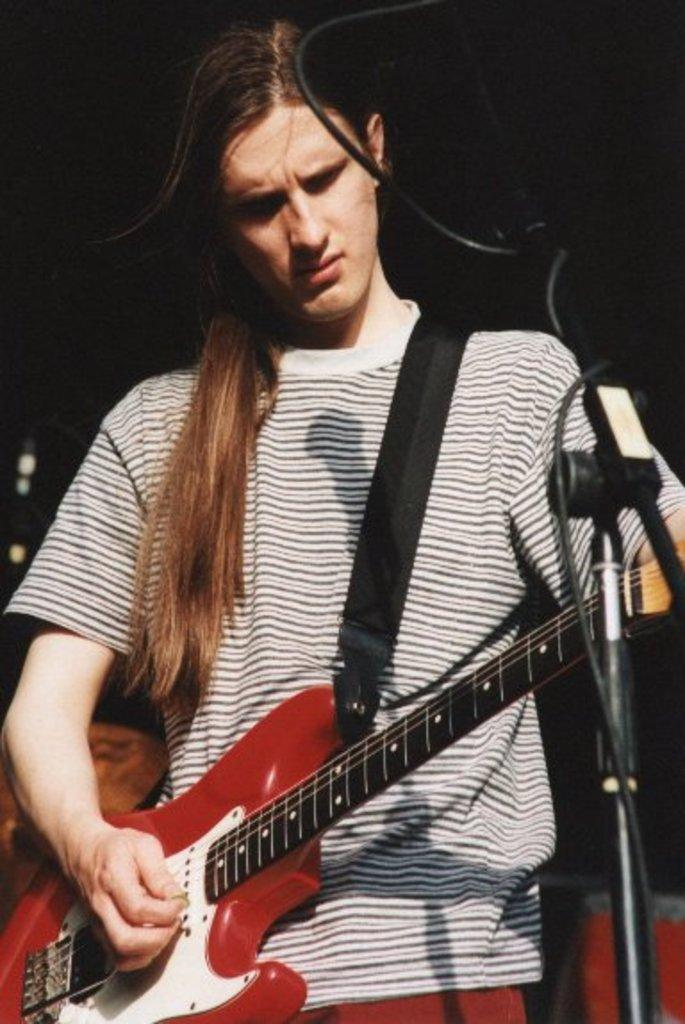What is the person in the image doing? The person is playing a guitar. What object is on the right side of the image? There is a microphone stand on the right side of the image. How would you describe the lighting in the image? The background of the image is dark. How many kittens are sitting on the person's wing in the image? There is no wing or kittens present in the image. 